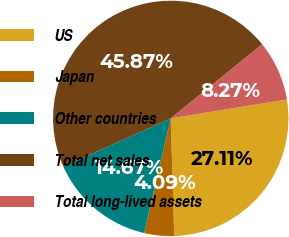<chart> <loc_0><loc_0><loc_500><loc_500><pie_chart><fcel>US<fcel>Japan<fcel>Other countries<fcel>Total net sales<fcel>Total long-lived assets<nl><fcel>27.11%<fcel>4.09%<fcel>14.67%<fcel>45.87%<fcel>8.27%<nl></chart> 